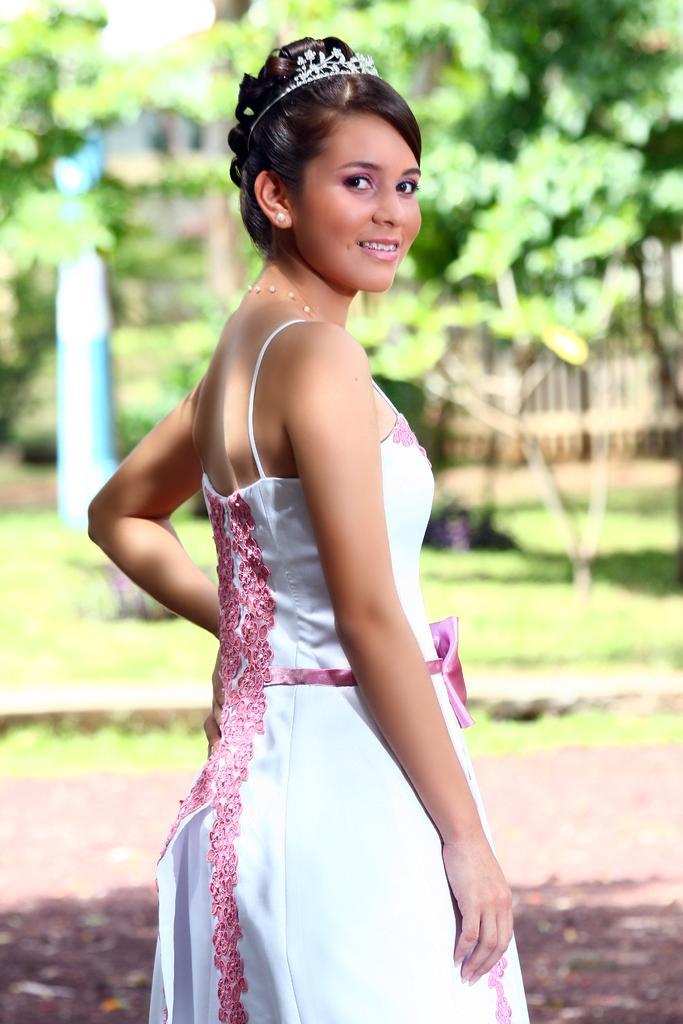Please provide a concise description of this image. Here in this picture we can see a woman wearing a white colored dress and standing over a place and she is smiling and we can see a tiara on her head and in the background we can see the ground is fully covered with grass and we can also see plants and trees in blurry manner. 